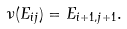Convert formula to latex. <formula><loc_0><loc_0><loc_500><loc_500>\nu ( E _ { i j } ) = E _ { i + 1 , j + 1 } .</formula> 